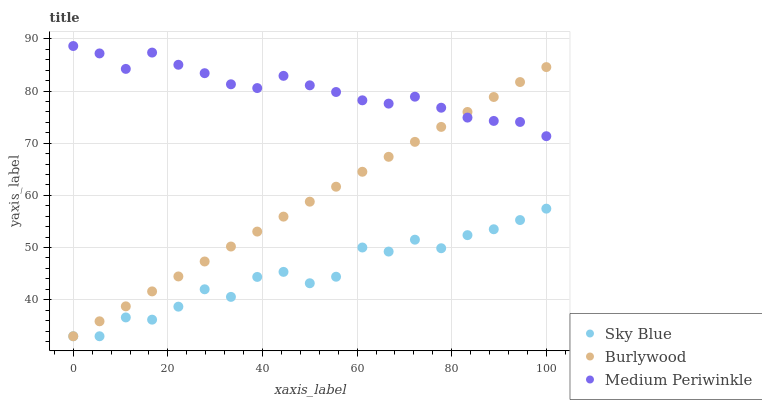Does Sky Blue have the minimum area under the curve?
Answer yes or no. Yes. Does Medium Periwinkle have the maximum area under the curve?
Answer yes or no. Yes. Does Medium Periwinkle have the minimum area under the curve?
Answer yes or no. No. Does Sky Blue have the maximum area under the curve?
Answer yes or no. No. Is Burlywood the smoothest?
Answer yes or no. Yes. Is Sky Blue the roughest?
Answer yes or no. Yes. Is Medium Periwinkle the smoothest?
Answer yes or no. No. Is Medium Periwinkle the roughest?
Answer yes or no. No. Does Burlywood have the lowest value?
Answer yes or no. Yes. Does Medium Periwinkle have the lowest value?
Answer yes or no. No. Does Medium Periwinkle have the highest value?
Answer yes or no. Yes. Does Sky Blue have the highest value?
Answer yes or no. No. Is Sky Blue less than Medium Periwinkle?
Answer yes or no. Yes. Is Medium Periwinkle greater than Sky Blue?
Answer yes or no. Yes. Does Burlywood intersect Medium Periwinkle?
Answer yes or no. Yes. Is Burlywood less than Medium Periwinkle?
Answer yes or no. No. Is Burlywood greater than Medium Periwinkle?
Answer yes or no. No. Does Sky Blue intersect Medium Periwinkle?
Answer yes or no. No. 